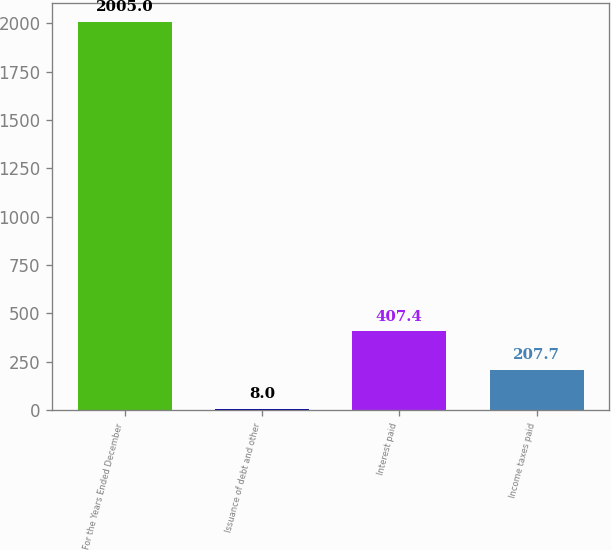Convert chart. <chart><loc_0><loc_0><loc_500><loc_500><bar_chart><fcel>For the Years Ended December<fcel>Issuance of debt and other<fcel>Interest paid<fcel>Income taxes paid<nl><fcel>2005<fcel>8<fcel>407.4<fcel>207.7<nl></chart> 